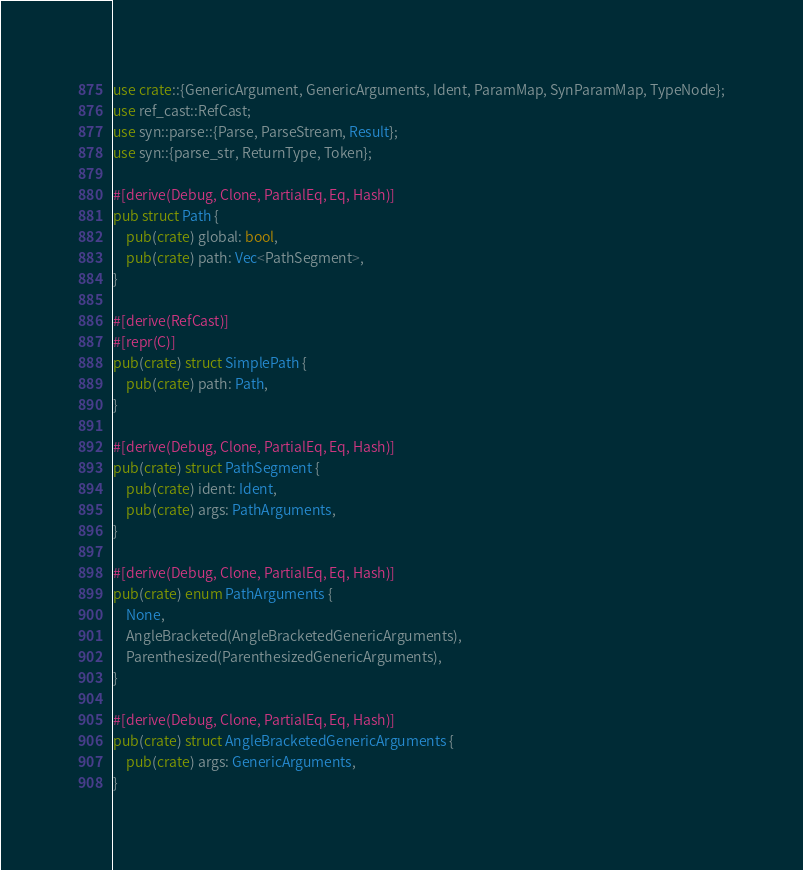<code> <loc_0><loc_0><loc_500><loc_500><_Rust_>use crate::{GenericArgument, GenericArguments, Ident, ParamMap, SynParamMap, TypeNode};
use ref_cast::RefCast;
use syn::parse::{Parse, ParseStream, Result};
use syn::{parse_str, ReturnType, Token};

#[derive(Debug, Clone, PartialEq, Eq, Hash)]
pub struct Path {
    pub(crate) global: bool,
    pub(crate) path: Vec<PathSegment>,
}

#[derive(RefCast)]
#[repr(C)]
pub(crate) struct SimplePath {
    pub(crate) path: Path,
}

#[derive(Debug, Clone, PartialEq, Eq, Hash)]
pub(crate) struct PathSegment {
    pub(crate) ident: Ident,
    pub(crate) args: PathArguments,
}

#[derive(Debug, Clone, PartialEq, Eq, Hash)]
pub(crate) enum PathArguments {
    None,
    AngleBracketed(AngleBracketedGenericArguments),
    Parenthesized(ParenthesizedGenericArguments),
}

#[derive(Debug, Clone, PartialEq, Eq, Hash)]
pub(crate) struct AngleBracketedGenericArguments {
    pub(crate) args: GenericArguments,
}
</code> 